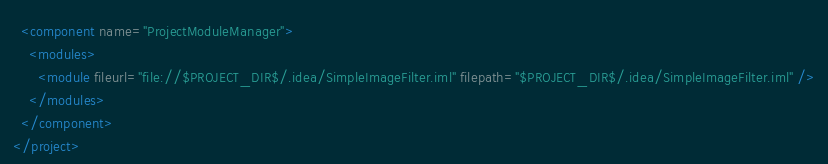Convert code to text. <code><loc_0><loc_0><loc_500><loc_500><_XML_>  <component name="ProjectModuleManager">
    <modules>
      <module fileurl="file://$PROJECT_DIR$/.idea/SimpleImageFilter.iml" filepath="$PROJECT_DIR$/.idea/SimpleImageFilter.iml" />
    </modules>
  </component>
</project></code> 